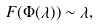Convert formula to latex. <formula><loc_0><loc_0><loc_500><loc_500>\ F ( \Phi ( \lambda ) ) \sim \lambda ,</formula> 